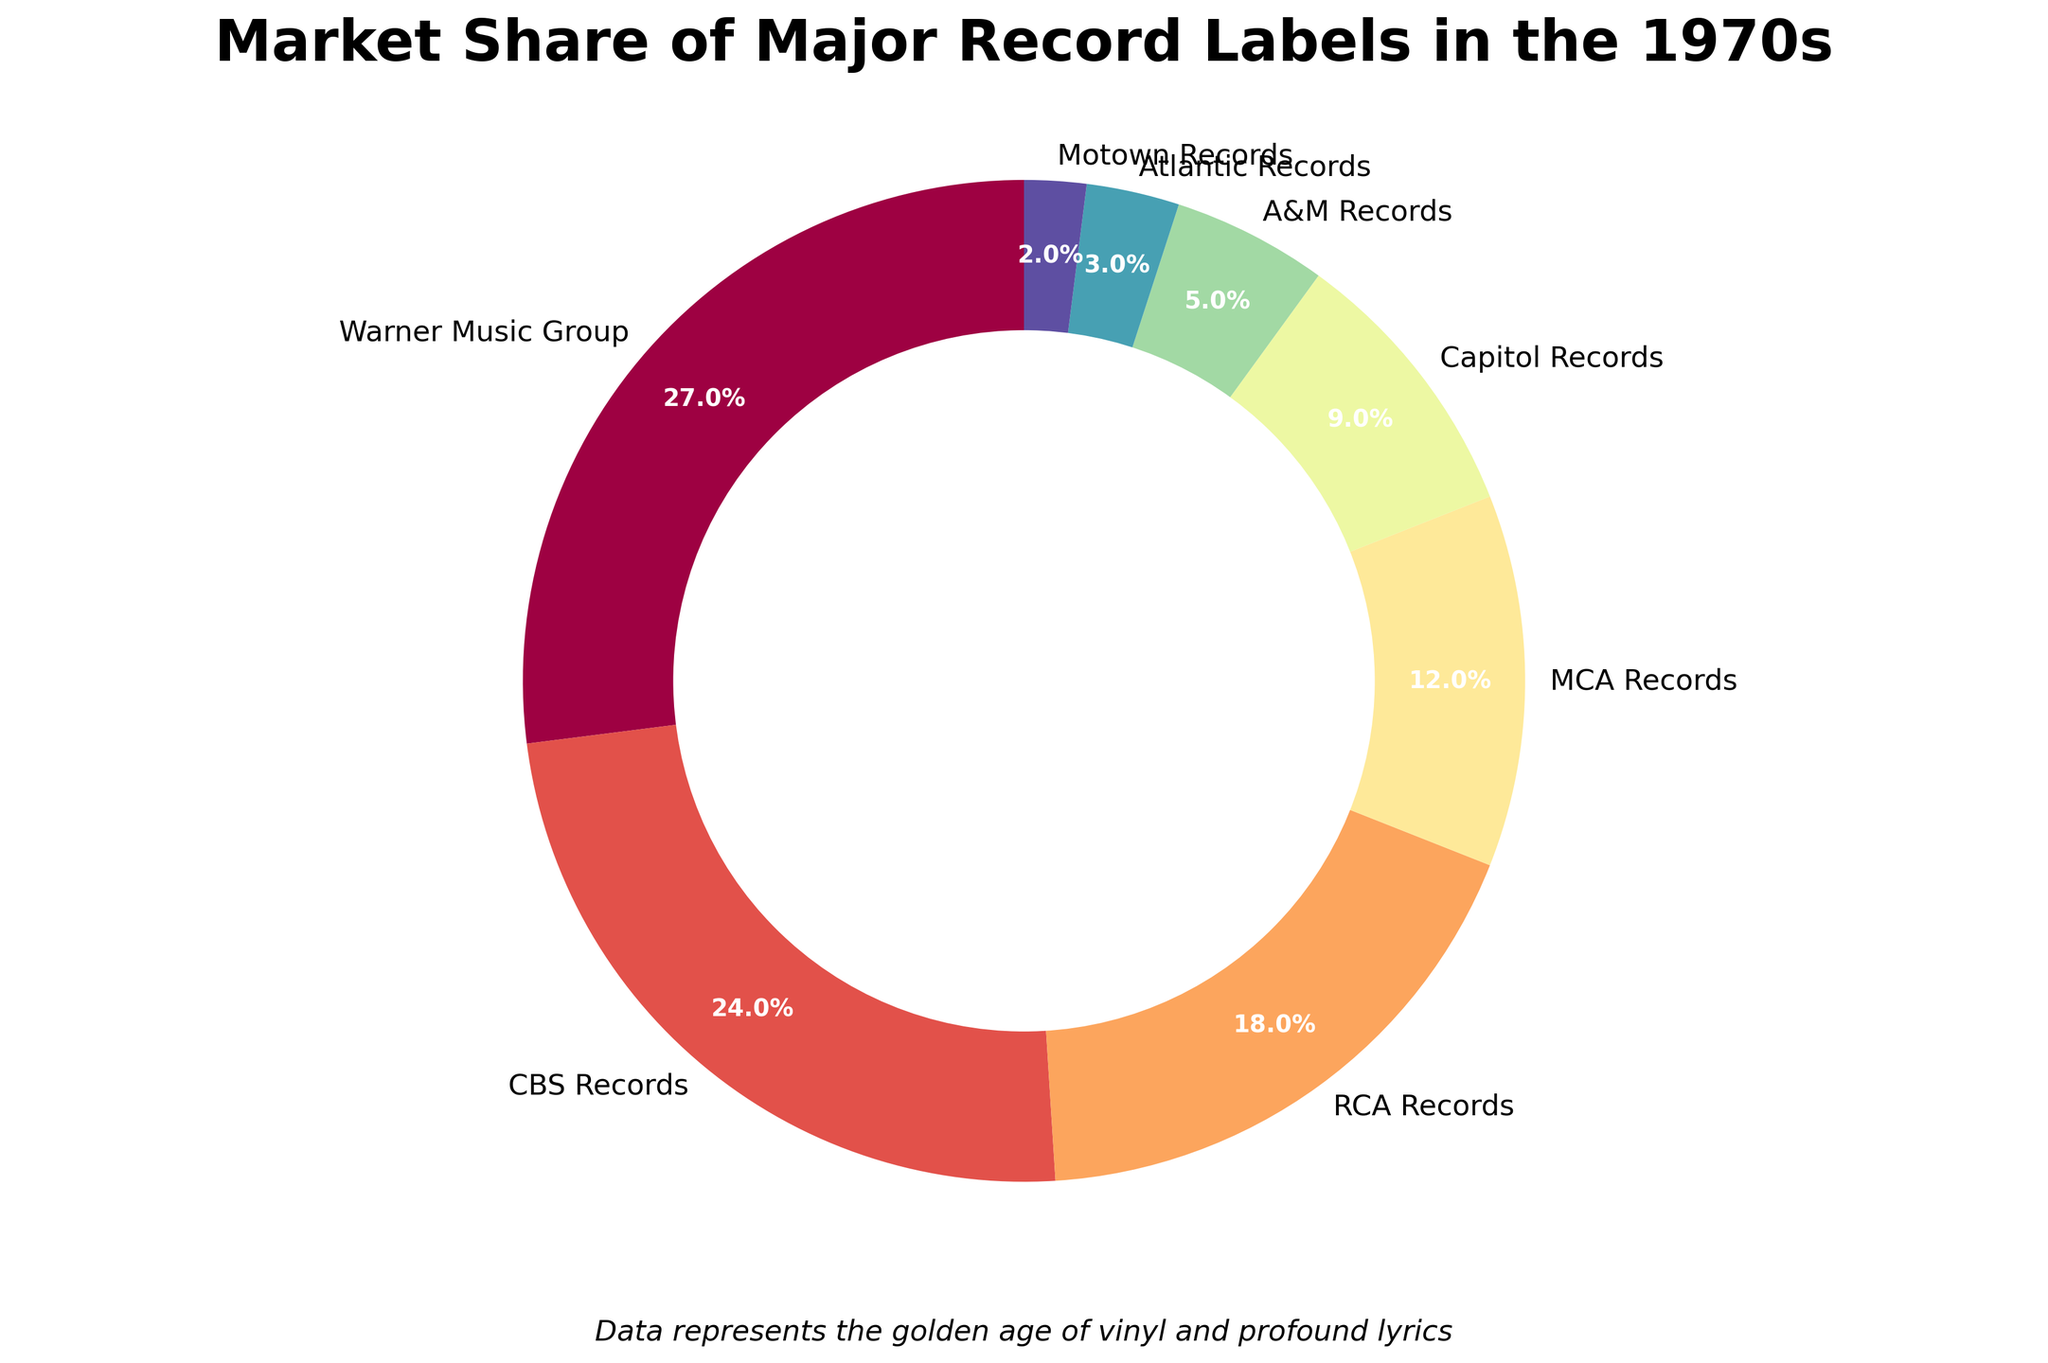What is the label with the largest market share? By inspecting the slices of the pie chart, the label with the largest slice can be identified. The largest slice corresponds to Warner Music Group with a 27% market share.
Answer: Warner Music Group Which label has the smallest market share and what is the percentage? On close inspection of the smallest slice in the pie chart, Motown Records holds the smallest share at 2%.
Answer: Motown Records, 2% What is the combined market share of CBS Records and RCA Records? To find the combined market share, add the individual percentages of CBS Records and RCA Records. Percentages are 24% for CBS Records and 18% for RCA Records. Thus, the combined market share is 24% + 18% = 42%.
Answer: 42% How much larger is the market share of Warner Music Group compared to Atlantic Records? Subtract the market share of Atlantic Records (3%) from Warner Music Group's market share (27%). This gives 27% - 3% = 24%.
Answer: 24% What is the total market share of the top three labels? Sum the market shares of Warner Music Group (27%), CBS Records (24%), and RCA Records (18%). This gives 27% + 24% + 18% = 69%.
Answer: 69% Which two labels together nearly make up half of the market? Adding the percentages of Warner Music Group (27%) and CBS Records (24%) gives a sum of 27% + 24% = 51%, which is nearly half.
Answer: Warner Music Group and CBS Records Rank the labels in descending order of market share. Observe the pie chart slices and their respective percentages to arrange them from largest to smallest market share as follows: Warner Music Group (27%), CBS Records (24%), RCA Records (18%), MCA Records (12%), Capitol Records (9%), A&M Records (5%), Atlantic Records (3%), and Motown Records (2%).
Answer: Warner Music Group, CBS Records, RCA Records, MCA Records, Capitol Records, A&M Records, Atlantic Records, Motown Records Which labels have a market share greater than 10%? Three market shares exceed 10% on the pie chart. These are Warner Music Group (27%), CBS Records (24%), and RCA Records (18%).
Answer: Warner Music Group, CBS Records, RCA Records What is the difference in market share between MCA Records and Capitol Records? Subtract Capitol Records' market share (9%) from MCA Records' market share (12%). This gives 12% - 9% = 3%.
Answer: 3% 